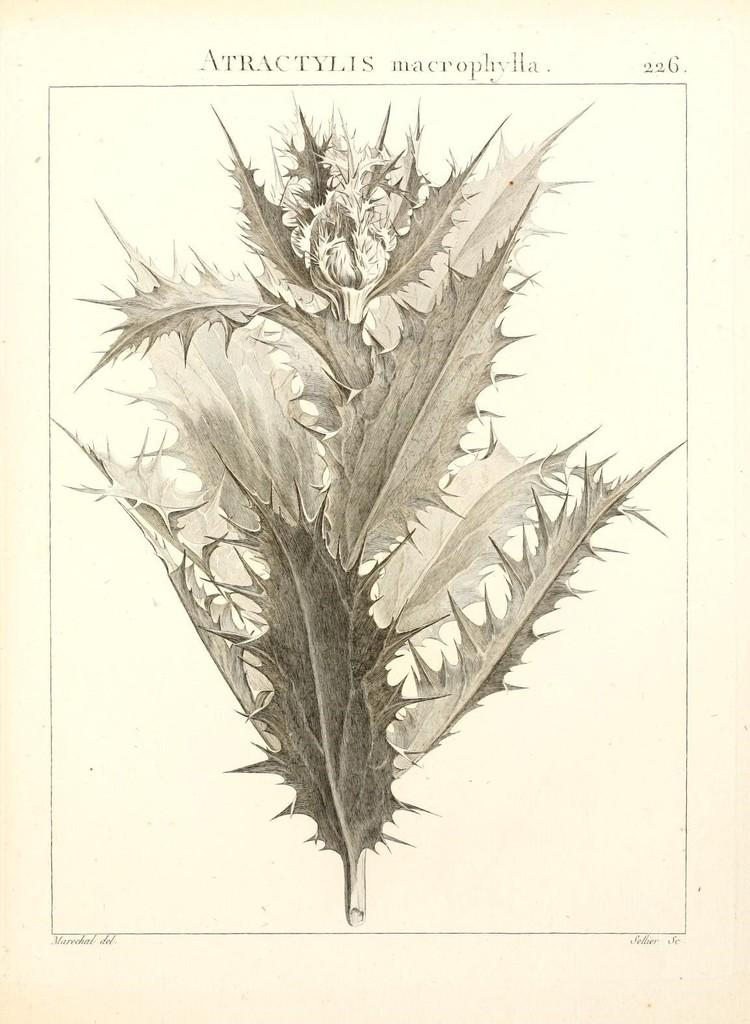What type of illustration is present on the page? There are leaves depicted on the page. What else can be found on the page besides the illustration? There is text on the page. How many robins can be seen perched on the leaves in the image? There are no robins present in the image; it only features leaves and text. What color is the eye of the robin in the image? There is no robin in the image, so there is no eye to describe. 